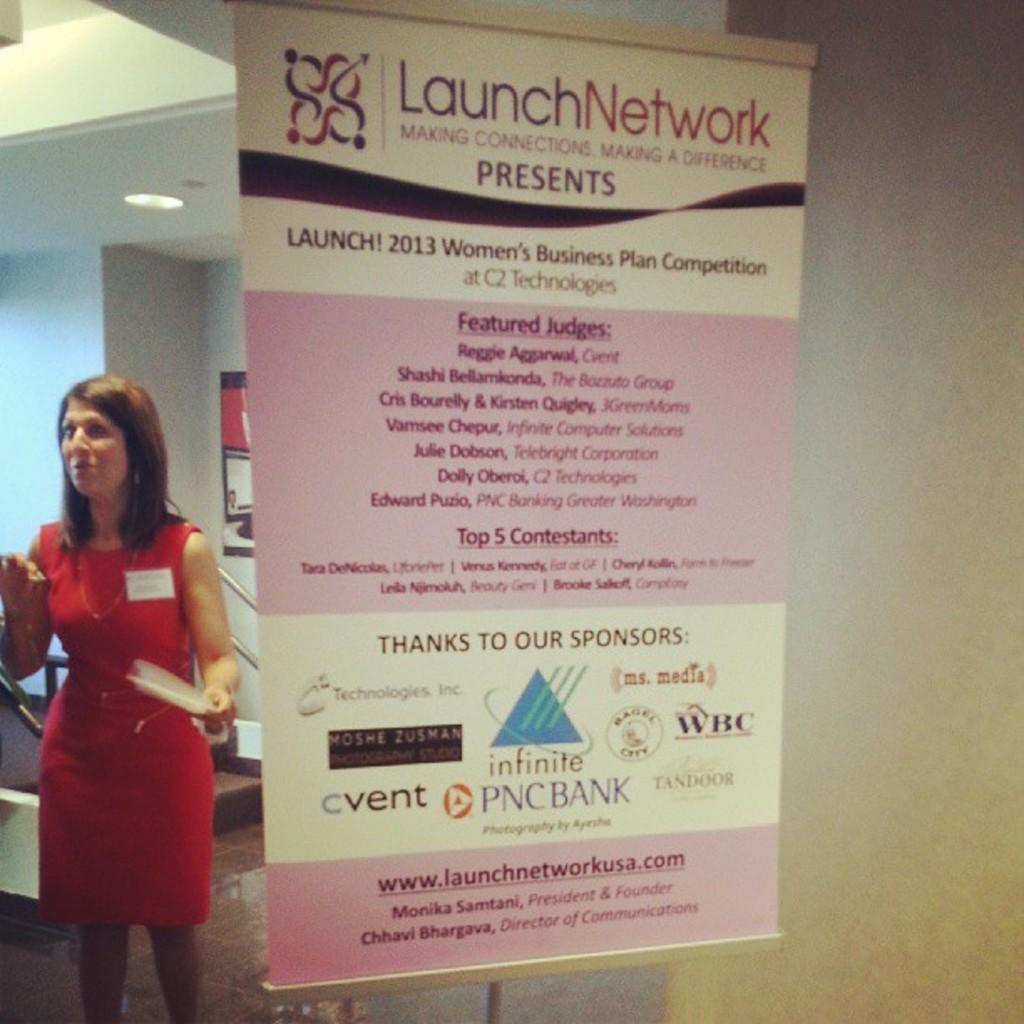What is featured on the poster in the image? There is a poster with text and logos in the image. What is the lady in the image doing? The lady is standing and holding a paper in the image. Can you describe the background of the image? There are objects visible in the background of the image. What type of throat-soothing remedy is present in the image? There is no throat-soothing remedy present in the image. Can you hear the bells ringing in the image? There are no bells present in the image, as it is a visual medium. 